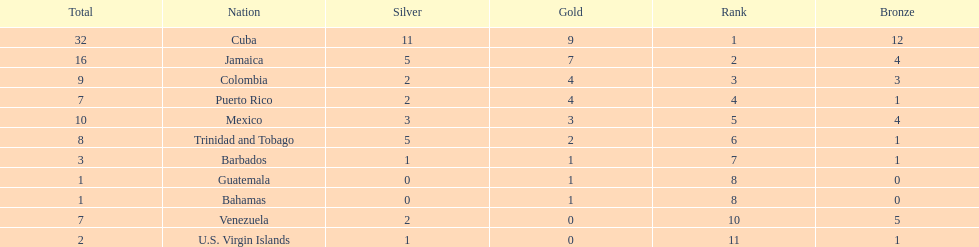Which country was awarded more than 5 silver medals? Cuba. 